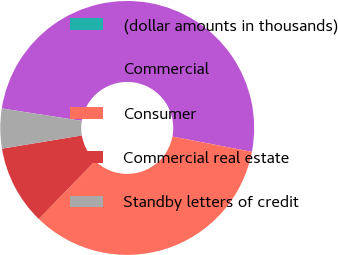Convert chart to OTSL. <chart><loc_0><loc_0><loc_500><loc_500><pie_chart><fcel>(dollar amounts in thousands)<fcel>Commercial<fcel>Consumer<fcel>Commercial real estate<fcel>Standby letters of credit<nl><fcel>0.01%<fcel>50.55%<fcel>34.26%<fcel>10.12%<fcel>5.06%<nl></chart> 